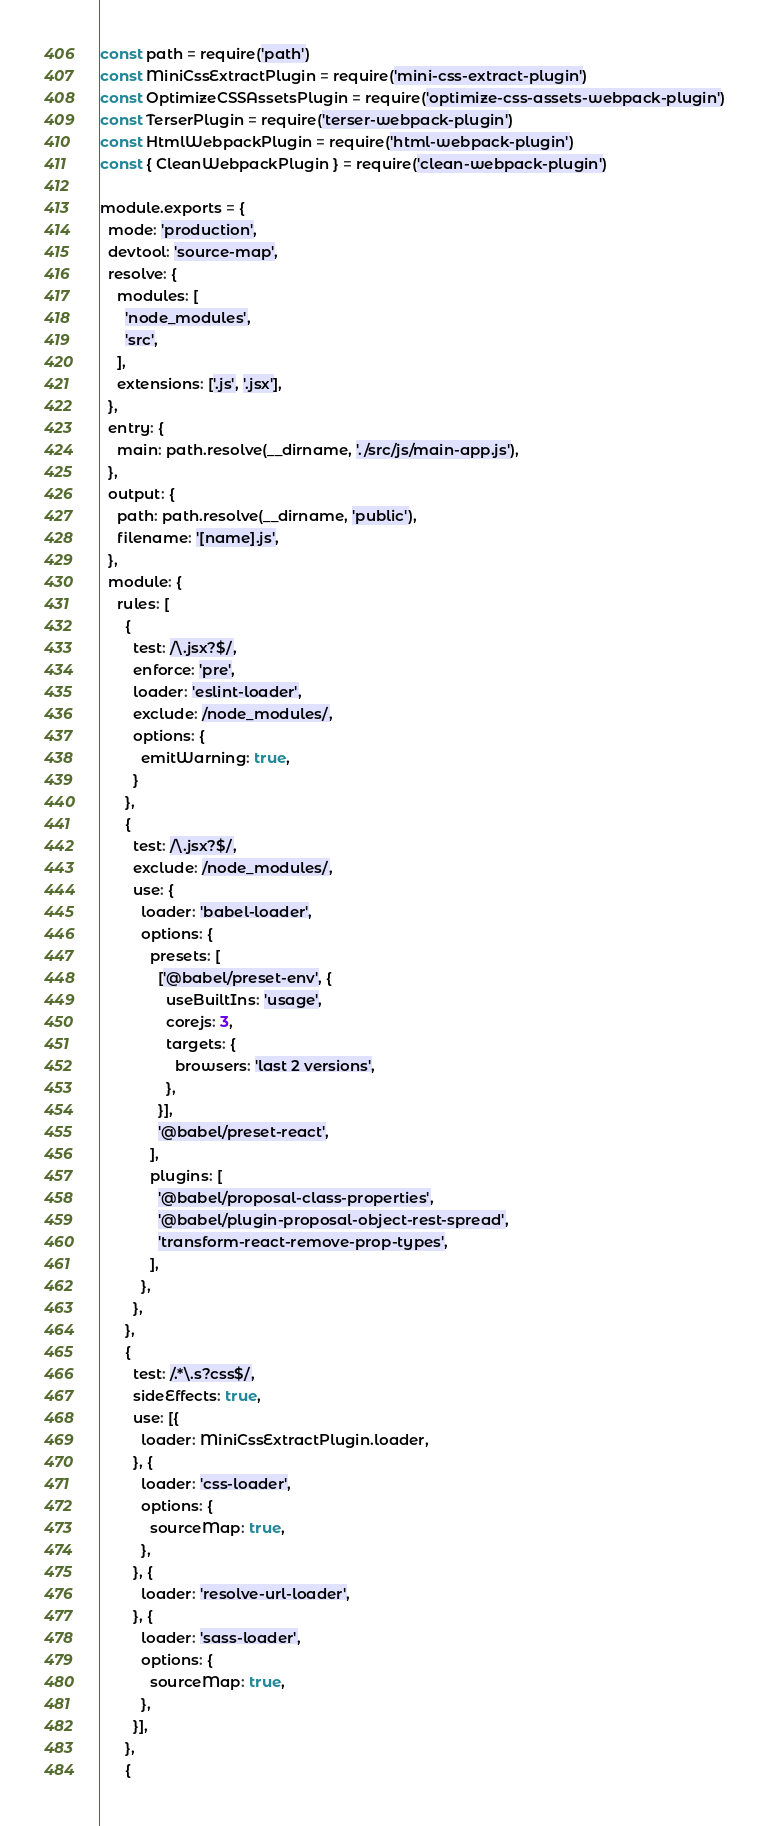<code> <loc_0><loc_0><loc_500><loc_500><_JavaScript_>const path = require('path')
const MiniCssExtractPlugin = require('mini-css-extract-plugin')
const OptimizeCSSAssetsPlugin = require('optimize-css-assets-webpack-plugin')
const TerserPlugin = require('terser-webpack-plugin')
const HtmlWebpackPlugin = require('html-webpack-plugin')
const { CleanWebpackPlugin } = require('clean-webpack-plugin')

module.exports = {
  mode: 'production',
  devtool: 'source-map',
  resolve: {
    modules: [
      'node_modules',
      'src',
    ],
    extensions: ['.js', '.jsx'],
  },
  entry: {
    main: path.resolve(__dirname, './src/js/main-app.js'),
  },
  output: {
    path: path.resolve(__dirname, 'public'),
    filename: '[name].js',
  },
  module: {
    rules: [
      {
        test: /\.jsx?$/,
        enforce: 'pre',
        loader: 'eslint-loader',
        exclude: /node_modules/,
        options: {
          emitWarning: true,
        }
      },
      {
        test: /\.jsx?$/,
        exclude: /node_modules/,
        use: {
          loader: 'babel-loader',
          options: {
            presets: [
              ['@babel/preset-env', {
                useBuiltIns: 'usage',
                corejs: 3,
                targets: {
                  browsers: 'last 2 versions',
                },
              }],
              '@babel/preset-react',
            ],
            plugins: [
              '@babel/proposal-class-properties',
              '@babel/plugin-proposal-object-rest-spread',
              'transform-react-remove-prop-types',
            ],
          },
        },
      },
      {
        test: /.*\.s?css$/,
        sideEffects: true,
        use: [{
          loader: MiniCssExtractPlugin.loader,
        }, {
          loader: 'css-loader',
          options: {
            sourceMap: true,
          },
        }, {
          loader: 'resolve-url-loader',
        }, {
          loader: 'sass-loader',
          options: {
            sourceMap: true,
          },
        }],
      },
      {</code> 